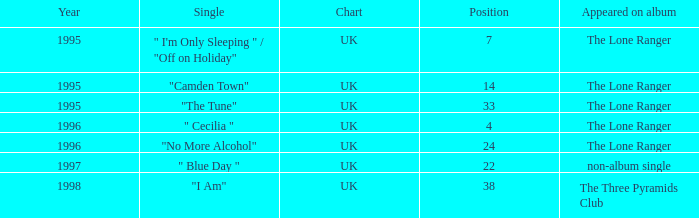What is the average position post-1996? 30.0. 